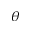<formula> <loc_0><loc_0><loc_500><loc_500>\theta</formula> 